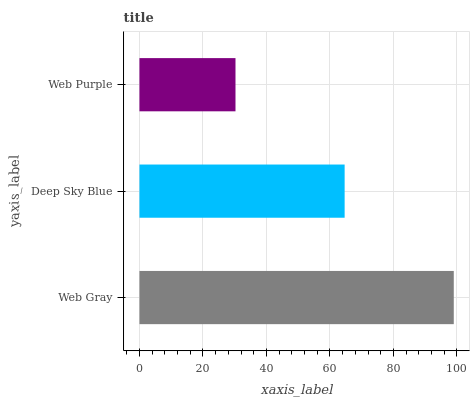Is Web Purple the minimum?
Answer yes or no. Yes. Is Web Gray the maximum?
Answer yes or no. Yes. Is Deep Sky Blue the minimum?
Answer yes or no. No. Is Deep Sky Blue the maximum?
Answer yes or no. No. Is Web Gray greater than Deep Sky Blue?
Answer yes or no. Yes. Is Deep Sky Blue less than Web Gray?
Answer yes or no. Yes. Is Deep Sky Blue greater than Web Gray?
Answer yes or no. No. Is Web Gray less than Deep Sky Blue?
Answer yes or no. No. Is Deep Sky Blue the high median?
Answer yes or no. Yes. Is Deep Sky Blue the low median?
Answer yes or no. Yes. Is Web Gray the high median?
Answer yes or no. No. Is Web Purple the low median?
Answer yes or no. No. 